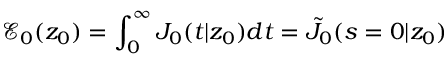<formula> <loc_0><loc_0><loc_500><loc_500>\mathcal { E } _ { 0 } ( z _ { 0 } ) = \int _ { 0 } ^ { \infty } J _ { 0 } ( t | z _ { 0 } ) d t = \tilde { J } _ { 0 } ( s = 0 | z _ { 0 } )</formula> 